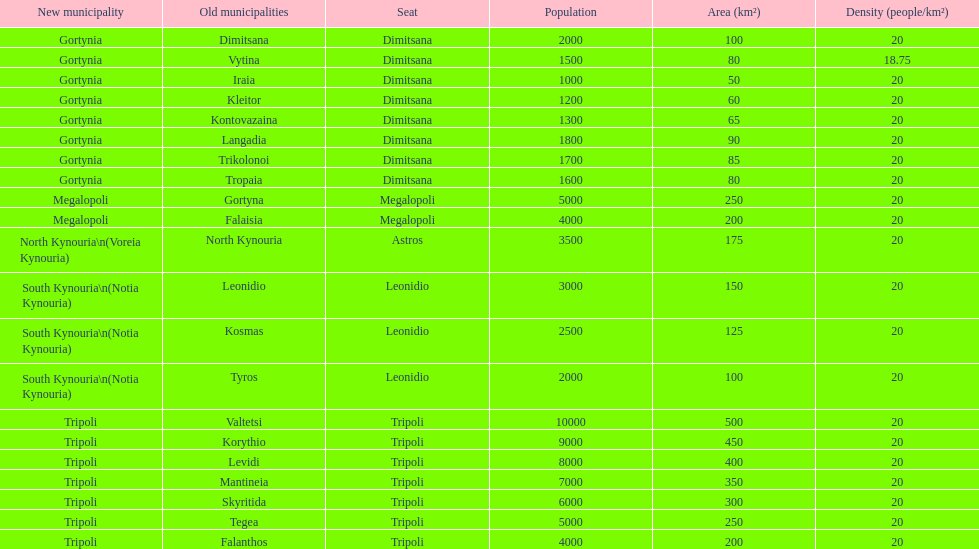How many old municipalities were in tripoli? 8. 